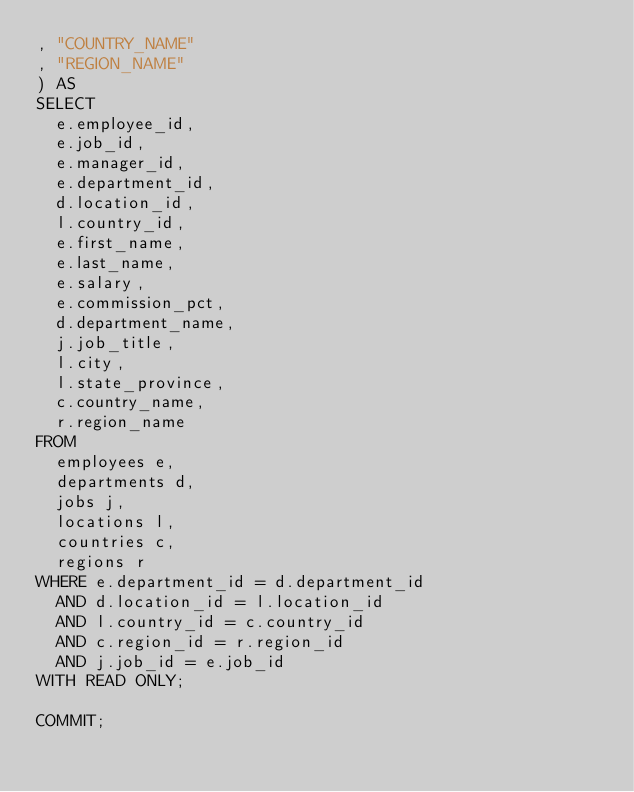<code> <loc_0><loc_0><loc_500><loc_500><_SQL_>, "COUNTRY_NAME"
, "REGION_NAME"
) AS
SELECT
  e.employee_id,
  e.job_id,
  e.manager_id,
  e.department_id,
  d.location_id,
  l.country_id,
  e.first_name,
  e.last_name,
  e.salary,
  e.commission_pct,
  d.department_name,
  j.job_title,
  l.city,
  l.state_province,
  c.country_name,
  r.region_name
FROM
  employees e,
  departments d,
  jobs j,
  locations l,
  countries c,
  regions r
WHERE e.department_id = d.department_id
  AND d.location_id = l.location_id
  AND l.country_id = c.country_id
  AND c.region_id = r.region_id
  AND j.job_id = e.job_id
WITH READ ONLY;

COMMIT;
</code> 